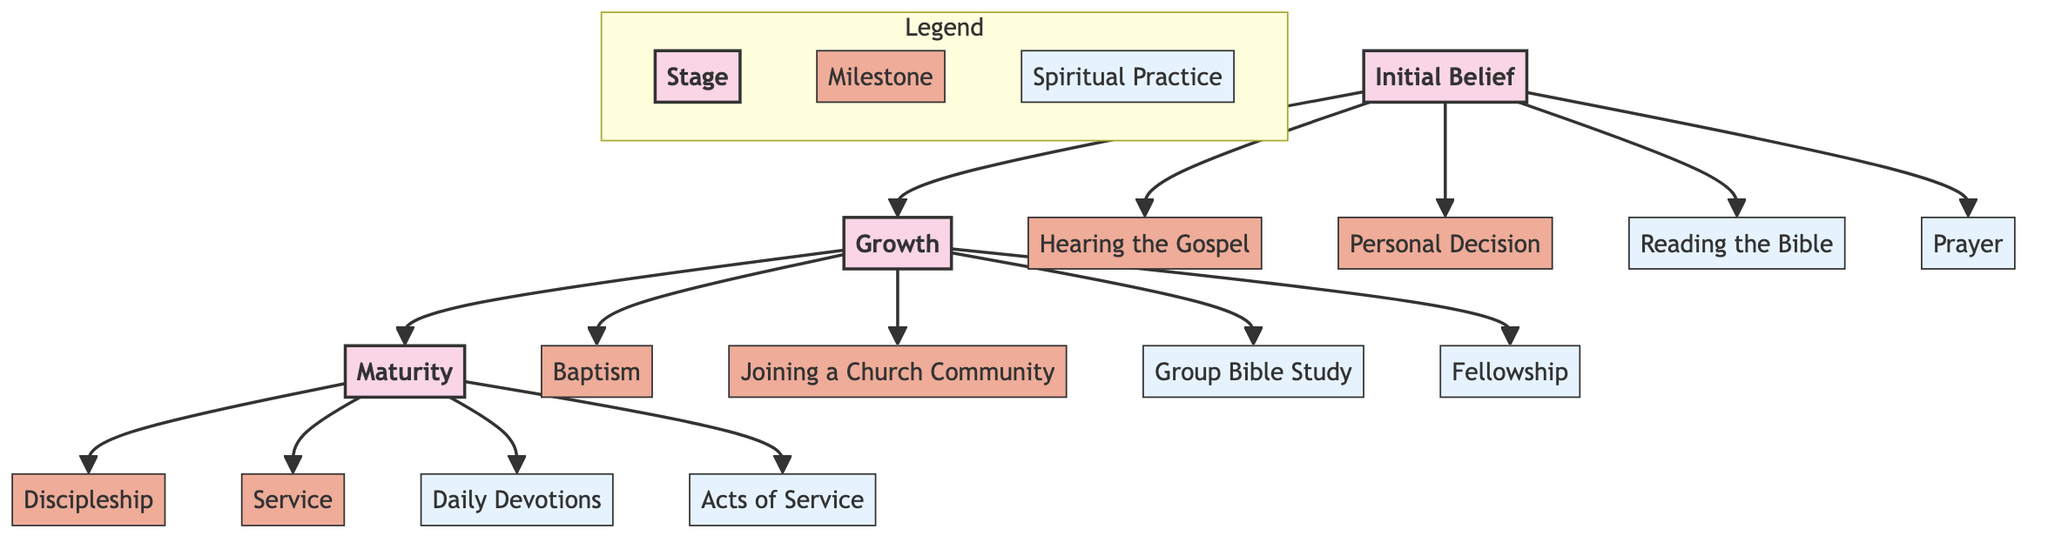What is the first stage of faith development? The diagram shows three stages: Initial Belief, Growth, and Maturity. The first listed stage is Initial Belief.
Answer: Initial Belief How many milestones are present in the Growth stage? From the Growth stage, there are three milestones: Baptism, Joining a Church Community, and one found in the next layer, Group Bible Study. Counting these gives a total of three.
Answer: 3 What spiritual practice is linked to the Maturity stage? The Maturity stage is associated with two spiritual practices: Daily Devotions and Acts of Service. The question does not specify a particular practice, thus either or both could be correct.
Answer: Daily Devotions Which milestone comes directly after Reading the Bible? Reading the Bible is a spiritual practice in the Initial stage. The next stage is Growth, and the first milestone after this stage is Baptism. Following the flow from Initial to Growth confirms it.
Answer: Baptism What is the total number of nodes in the diagram? To determine the total number of nodes, we can count: there are three stages, six milestones, and four practices, resulting in a total of 13 nodes.
Answer: 13 What is one of the practices involved in the Growth stage? Within the Growth stage, there are two practices: Group Bible Study and Fellowship. Either of these can answer the question as they both represent practices in this stage.
Answer: Group Bible Study Which two practices are present in the Maturity stage? In this stage, two practices are mentioned: Daily Devotions and Acts of Service. By checking the Maturity node, both practices are visually listed and verified.
Answer: Daily Devotions, Acts of Service What is the relationship between the Initial and Growth stages? The relationship is sequential as the flow goes from Initial directly to Growth, indicating that Growth follows Initial in the faith development journey.
Answer: Growth follows Initial What is one milestone in the Initial stage? There are several options in the Initial stage, including Hearing the Gospel, Personal Decision, and Prayer. Each one is valid as a milestone.
Answer: Hearing the Gospel 